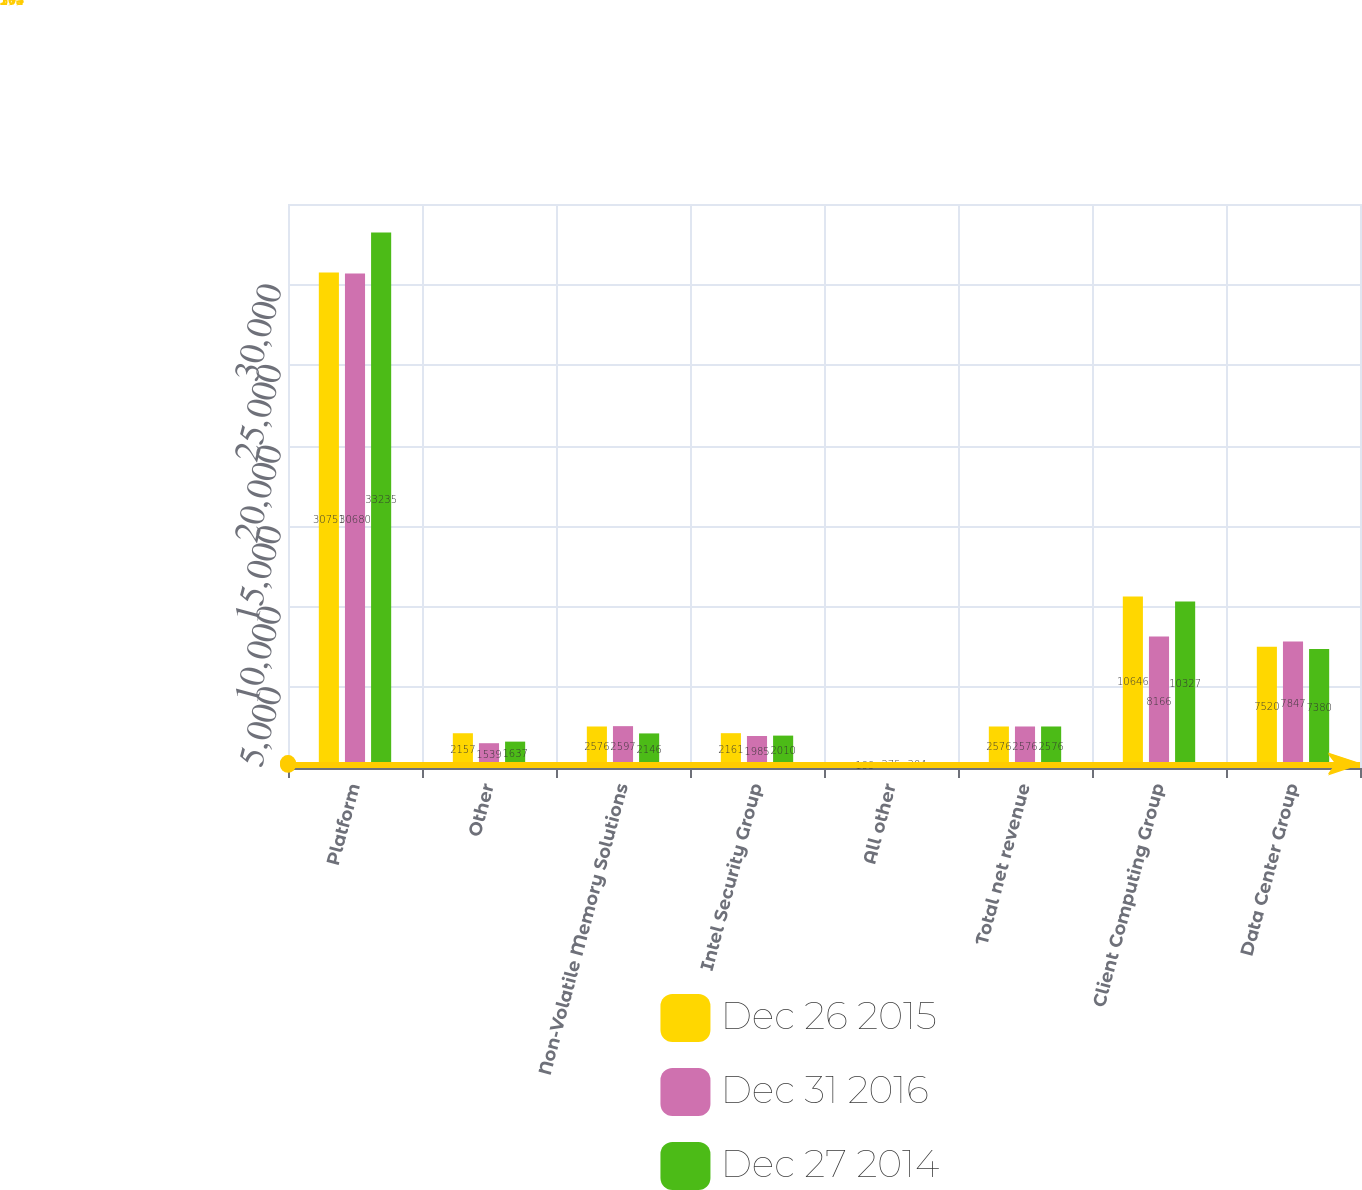Convert chart to OTSL. <chart><loc_0><loc_0><loc_500><loc_500><stacked_bar_chart><ecel><fcel>Platform<fcel>Other<fcel>Non-Volatile Memory Solutions<fcel>Intel Security Group<fcel>All other<fcel>Total net revenue<fcel>Client Computing Group<fcel>Data Center Group<nl><fcel>Dec 26 2015<fcel>30751<fcel>2157<fcel>2576<fcel>2161<fcel>199<fcel>2576<fcel>10646<fcel>7520<nl><fcel>Dec 31 2016<fcel>30680<fcel>1539<fcel>2597<fcel>1985<fcel>275<fcel>2576<fcel>8166<fcel>7847<nl><fcel>Dec 27 2014<fcel>33235<fcel>1637<fcel>2146<fcel>2010<fcel>304<fcel>2576<fcel>10327<fcel>7380<nl></chart> 